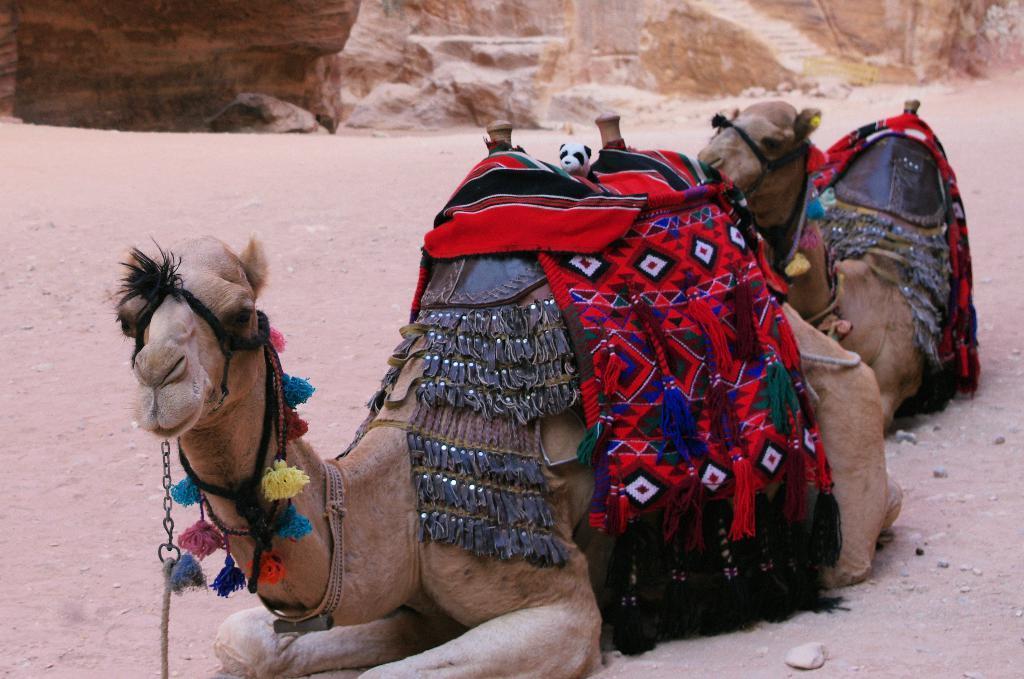Describe this image in one or two sentences. In the image there are two camels laying on the land, there are colorful cloth on its back, in the background there are sand hills. 